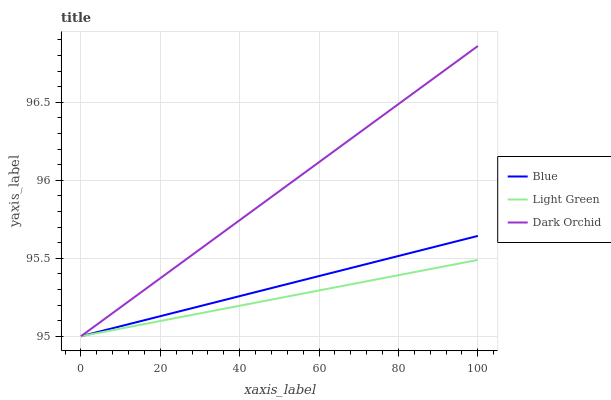Does Light Green have the minimum area under the curve?
Answer yes or no. Yes. Does Dark Orchid have the maximum area under the curve?
Answer yes or no. Yes. Does Dark Orchid have the minimum area under the curve?
Answer yes or no. No. Does Light Green have the maximum area under the curve?
Answer yes or no. No. Is Blue the smoothest?
Answer yes or no. Yes. Is Dark Orchid the roughest?
Answer yes or no. Yes. Is Dark Orchid the smoothest?
Answer yes or no. No. Is Light Green the roughest?
Answer yes or no. No. Does Blue have the lowest value?
Answer yes or no. Yes. Does Dark Orchid have the highest value?
Answer yes or no. Yes. Does Light Green have the highest value?
Answer yes or no. No. Does Light Green intersect Blue?
Answer yes or no. Yes. Is Light Green less than Blue?
Answer yes or no. No. Is Light Green greater than Blue?
Answer yes or no. No. 